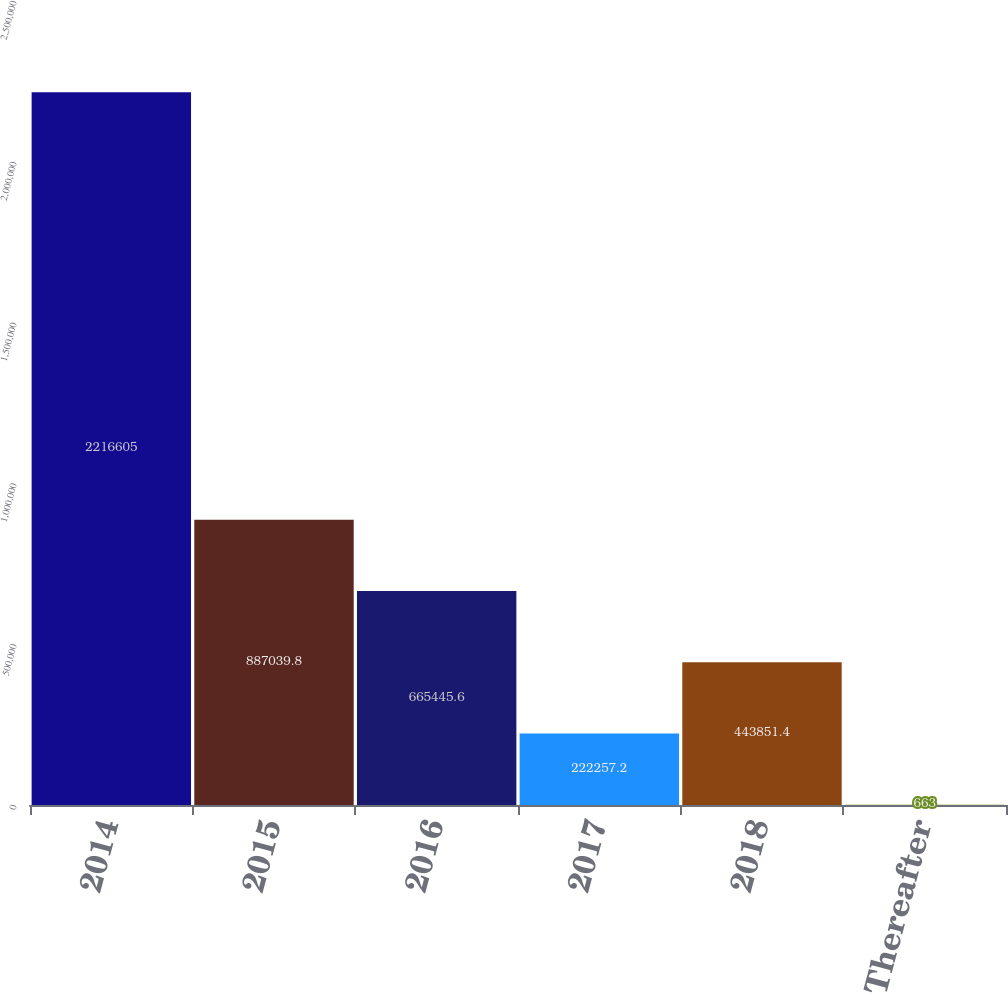<chart> <loc_0><loc_0><loc_500><loc_500><bar_chart><fcel>2014<fcel>2015<fcel>2016<fcel>2017<fcel>2018<fcel>Thereafter<nl><fcel>2.2166e+06<fcel>887040<fcel>665446<fcel>222257<fcel>443851<fcel>663<nl></chart> 